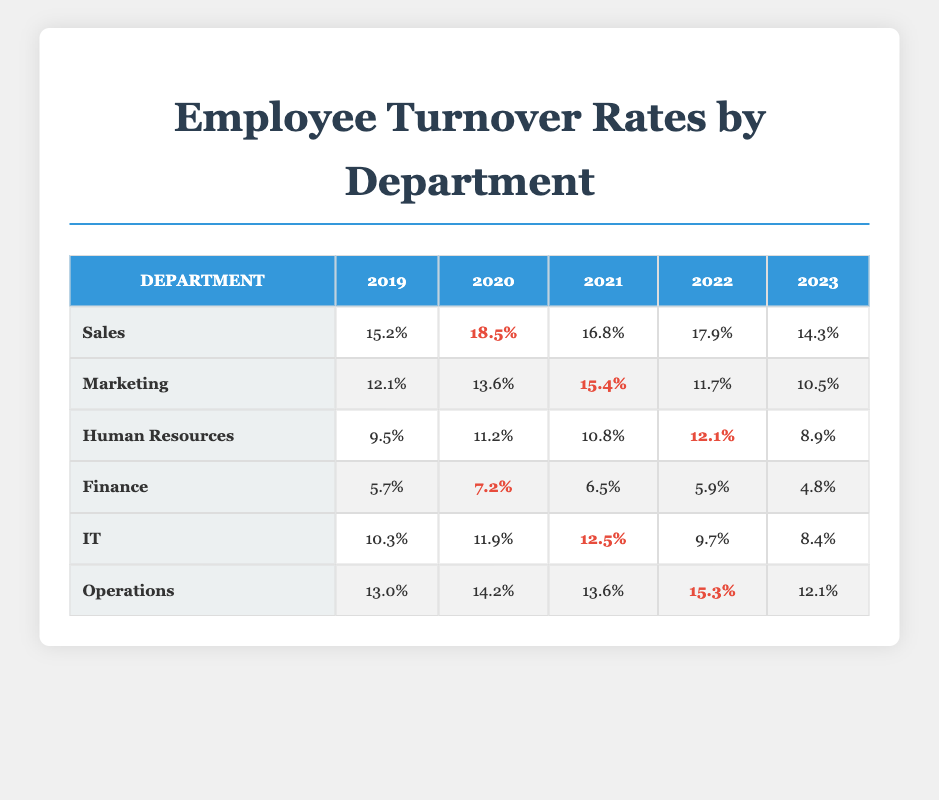What was the highest employee turnover rate in the Sales department? Looking at the Sales department row, the turnover rates for the years are: 15.2, 18.5, 16.8, 17.9, and 14.3. The highest value among these is 18.5 in 2020.
Answer: 18.5 Which department had the lowest turnover rate in 2023? Inspecting the turnover rates of all departments for 2023, we have the following values: Sales 14.3, Marketing 10.5, Human Resources 8.9, Finance 4.8, IT 8.4, and Operations 12.1. The lowest value is 4.8 from the Finance department.
Answer: Finance What was the average turnover rate in the Marketing department over five years? The turnover rates for Marketing over the years are: 12.1, 13.6, 15.4, 11.7, and 10.5. Summing these gives 12.1 + 13.6 + 15.4 + 11.7 + 10.5 = 63.3. Dividing by 5 (the number of years) gives 63.3 / 5 = 12.66.
Answer: 12.66 Is it true that the turnover rate for Human Resources was higher than 11% in 2020? In the Human Resources row, the turnover rate for 2020 is 11.2%. Since 11.2 is greater than 11, the statement is true.
Answer: Yes Which department experienced the largest year-over-year increase in turnover from 2019 to 2020? Analyzing the changes in turnover rates from 2019 to 2020: Sales increased from 15.2 to 18.5 (3.3), Marketing increased from 12.1 to 13.6 (1.5), Human Resources increased from 9.5 to 11.2 (1.7), Finance increased from 5.7 to 7.2 (1.5), IT increased from 10.3 to 11.9 (1.6), and Operations increased from 13.0 to 14.2 (1.2). The highest increase is 3.3 in Sales.
Answer: Sales What were the turnover rates in 2022 for both the Finance and IT departments? For Finance in 2022, the rate is 5.9, and for IT in 2022, it is 9.7. Both values can be found directly in their respective rows for 2022.
Answer: Finance 5.9, IT 9.7 What is the overall trend of turnover rates in the IT department from 2019 to 2023? The turnover rates for IT are: 10.3, 11.9, 12.5, 9.7, and 8.4. The rates increased from 2019 to 2021, peaking at 12.5, then decreased over the following two years, ultimately dropping to 8.4 in 2023. Therefore, the trend shows an initial increase followed by a decline.
Answer: Increase then decline Which two departments had the highest turnover rates in 2021? In 2021, the turnover rates were Sales 16.8, Marketing 15.4, Human Resources 10.8, Finance 6.5, IT 12.5, and Operations 13.6. The two highest rates are from Sales and Marketing, as they are greater than all others in that year.
Answer: Sales and Marketing 